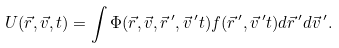Convert formula to latex. <formula><loc_0><loc_0><loc_500><loc_500>U ( \vec { r } , \vec { v } , t ) = \int \Phi ( \vec { r } , \vec { v } , \vec { r } \, ^ { \prime } , \vec { v } \, ^ { \prime } t ) f ( \vec { r } \, ^ { \prime } , \vec { v } \, ^ { \prime } t ) d \vec { r } \, ^ { \prime } d \vec { v } \, ^ { \prime } .</formula> 